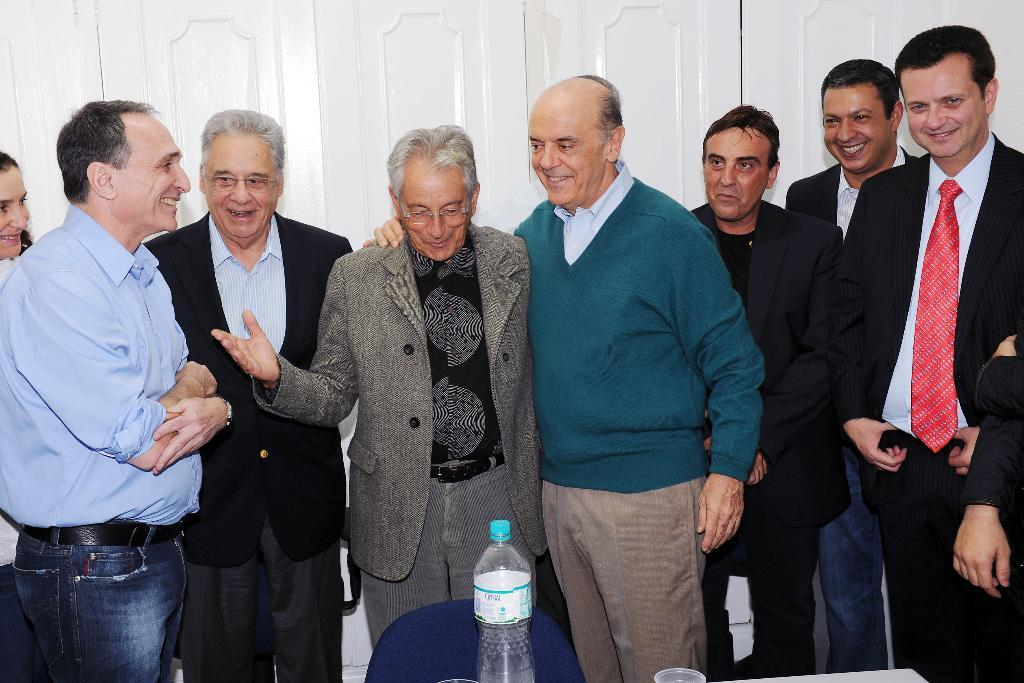What is happening with the group of people in the image? The people in the image are smiling. What objects can be seen in the image besides the people? There is a table, a chair, and a bottle in the image. What is the color of the background in the image? The background of the image is white. What day of the week is it in the image? The day of the week is not mentioned or depicted in the image. What achievement is the person in the image celebrating? There is no person celebrating an achievement in the image; it only shows a group of people smiling. 